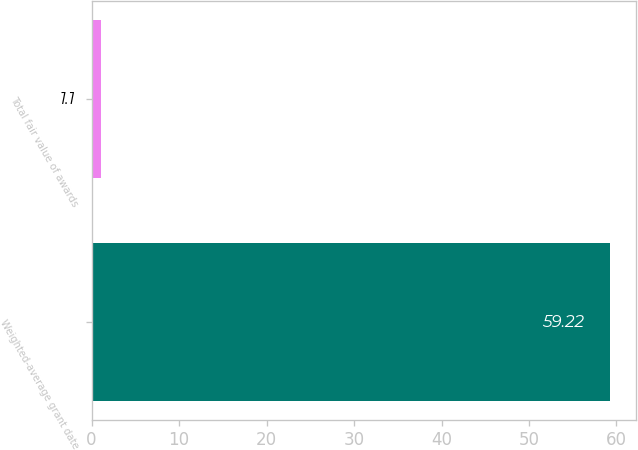Convert chart. <chart><loc_0><loc_0><loc_500><loc_500><bar_chart><fcel>Weighted-average grant date<fcel>Total fair value of awards<nl><fcel>59.22<fcel>1.1<nl></chart> 